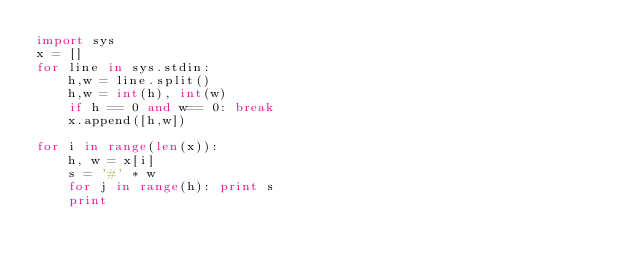Convert code to text. <code><loc_0><loc_0><loc_500><loc_500><_Python_>import sys
x = []
for line in sys.stdin:
    h,w = line.split()
    h,w = int(h), int(w)
    if h == 0 and w== 0: break
    x.append([h,w])

for i in range(len(x)):
    h, w = x[i]
    s = '#' * w
    for j in range(h): print s
    print
    </code> 